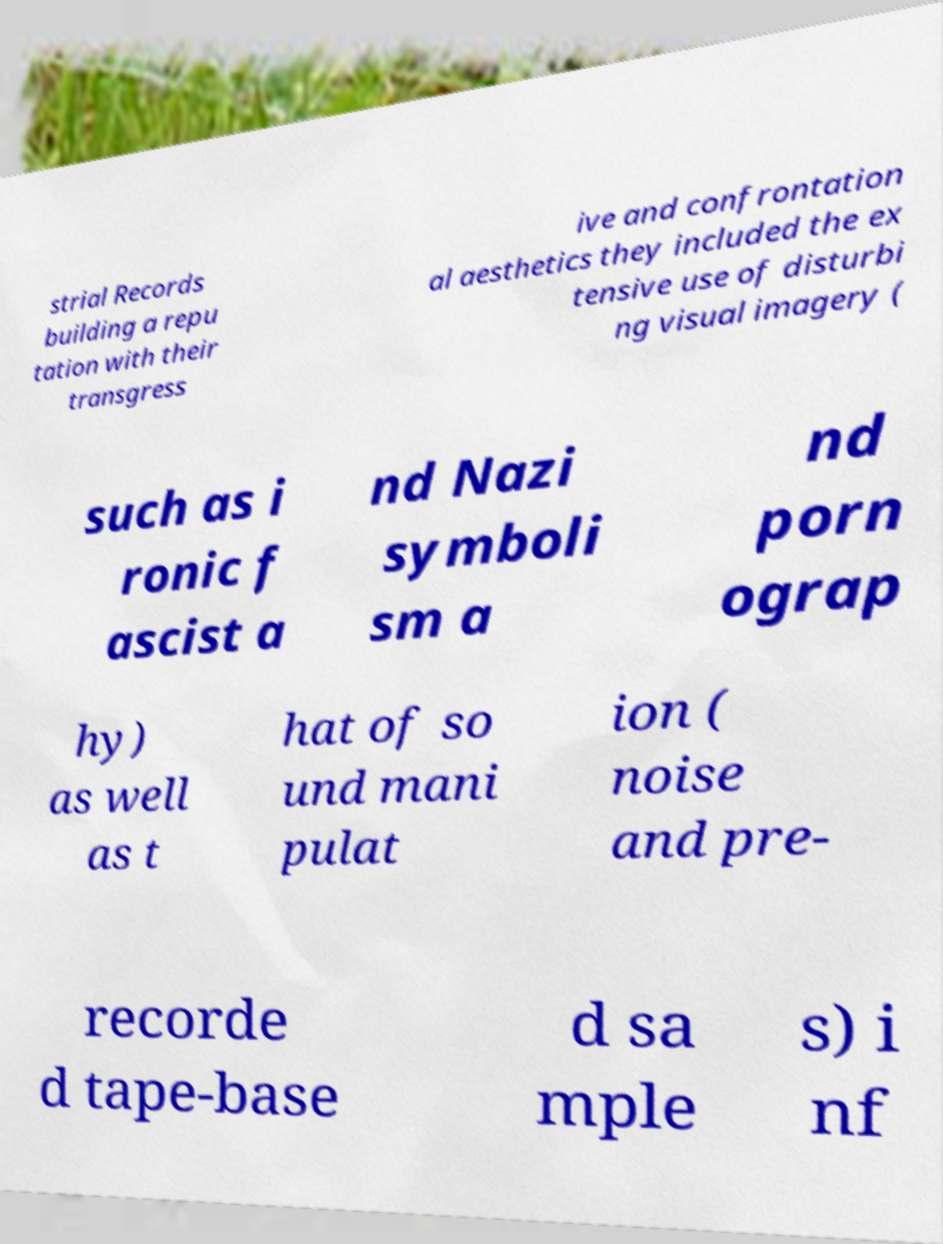Please read and relay the text visible in this image. What does it say? strial Records building a repu tation with their transgress ive and confrontation al aesthetics they included the ex tensive use of disturbi ng visual imagery ( such as i ronic f ascist a nd Nazi symboli sm a nd porn ograp hy) as well as t hat of so und mani pulat ion ( noise and pre- recorde d tape-base d sa mple s) i nf 